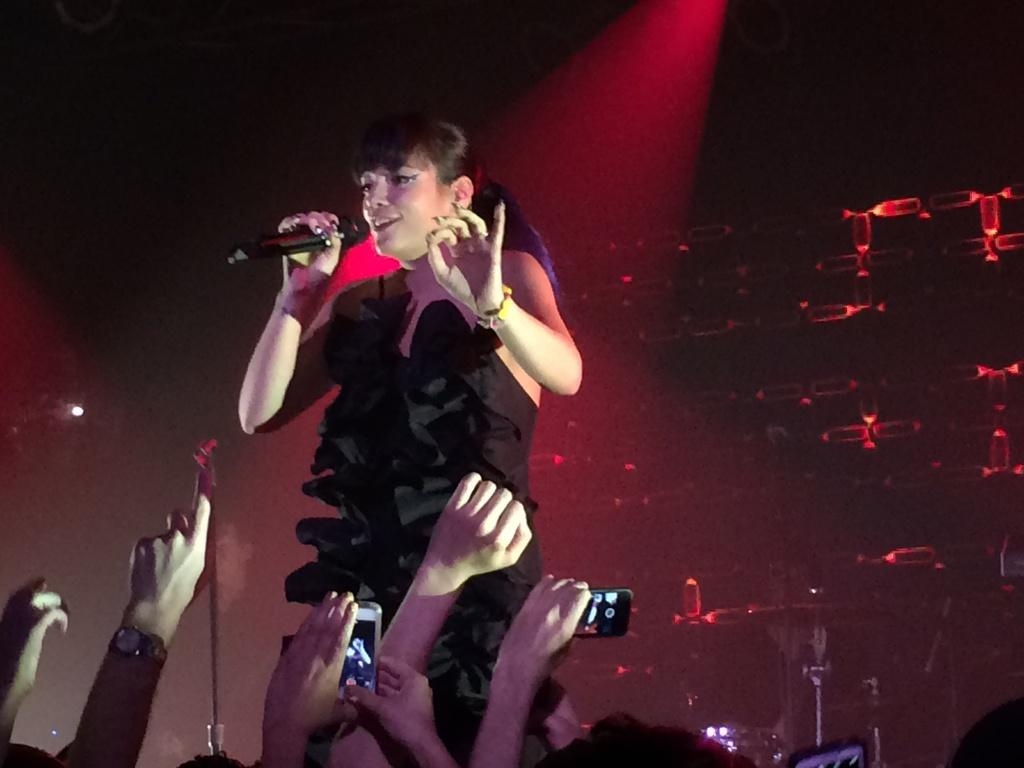What is the main subject of the image? The main subject of the image is a woman. What is the woman doing in the image? The woman is standing and smiling in the image. What object is the woman holding in her hand? The woman is holding a microphone in her hand. Are there any other people in the image? Yes, there is a group of persons in the image. What type of pail is being used to improve the woman's hearing in the image? There is no pail or reference to hearing improvement in the image; the woman is holding a microphone. What health concerns might the woman be addressing in the image? A: There is no information about health concerns in the image; the woman is simply standing, smiling, and holding a microphone. 